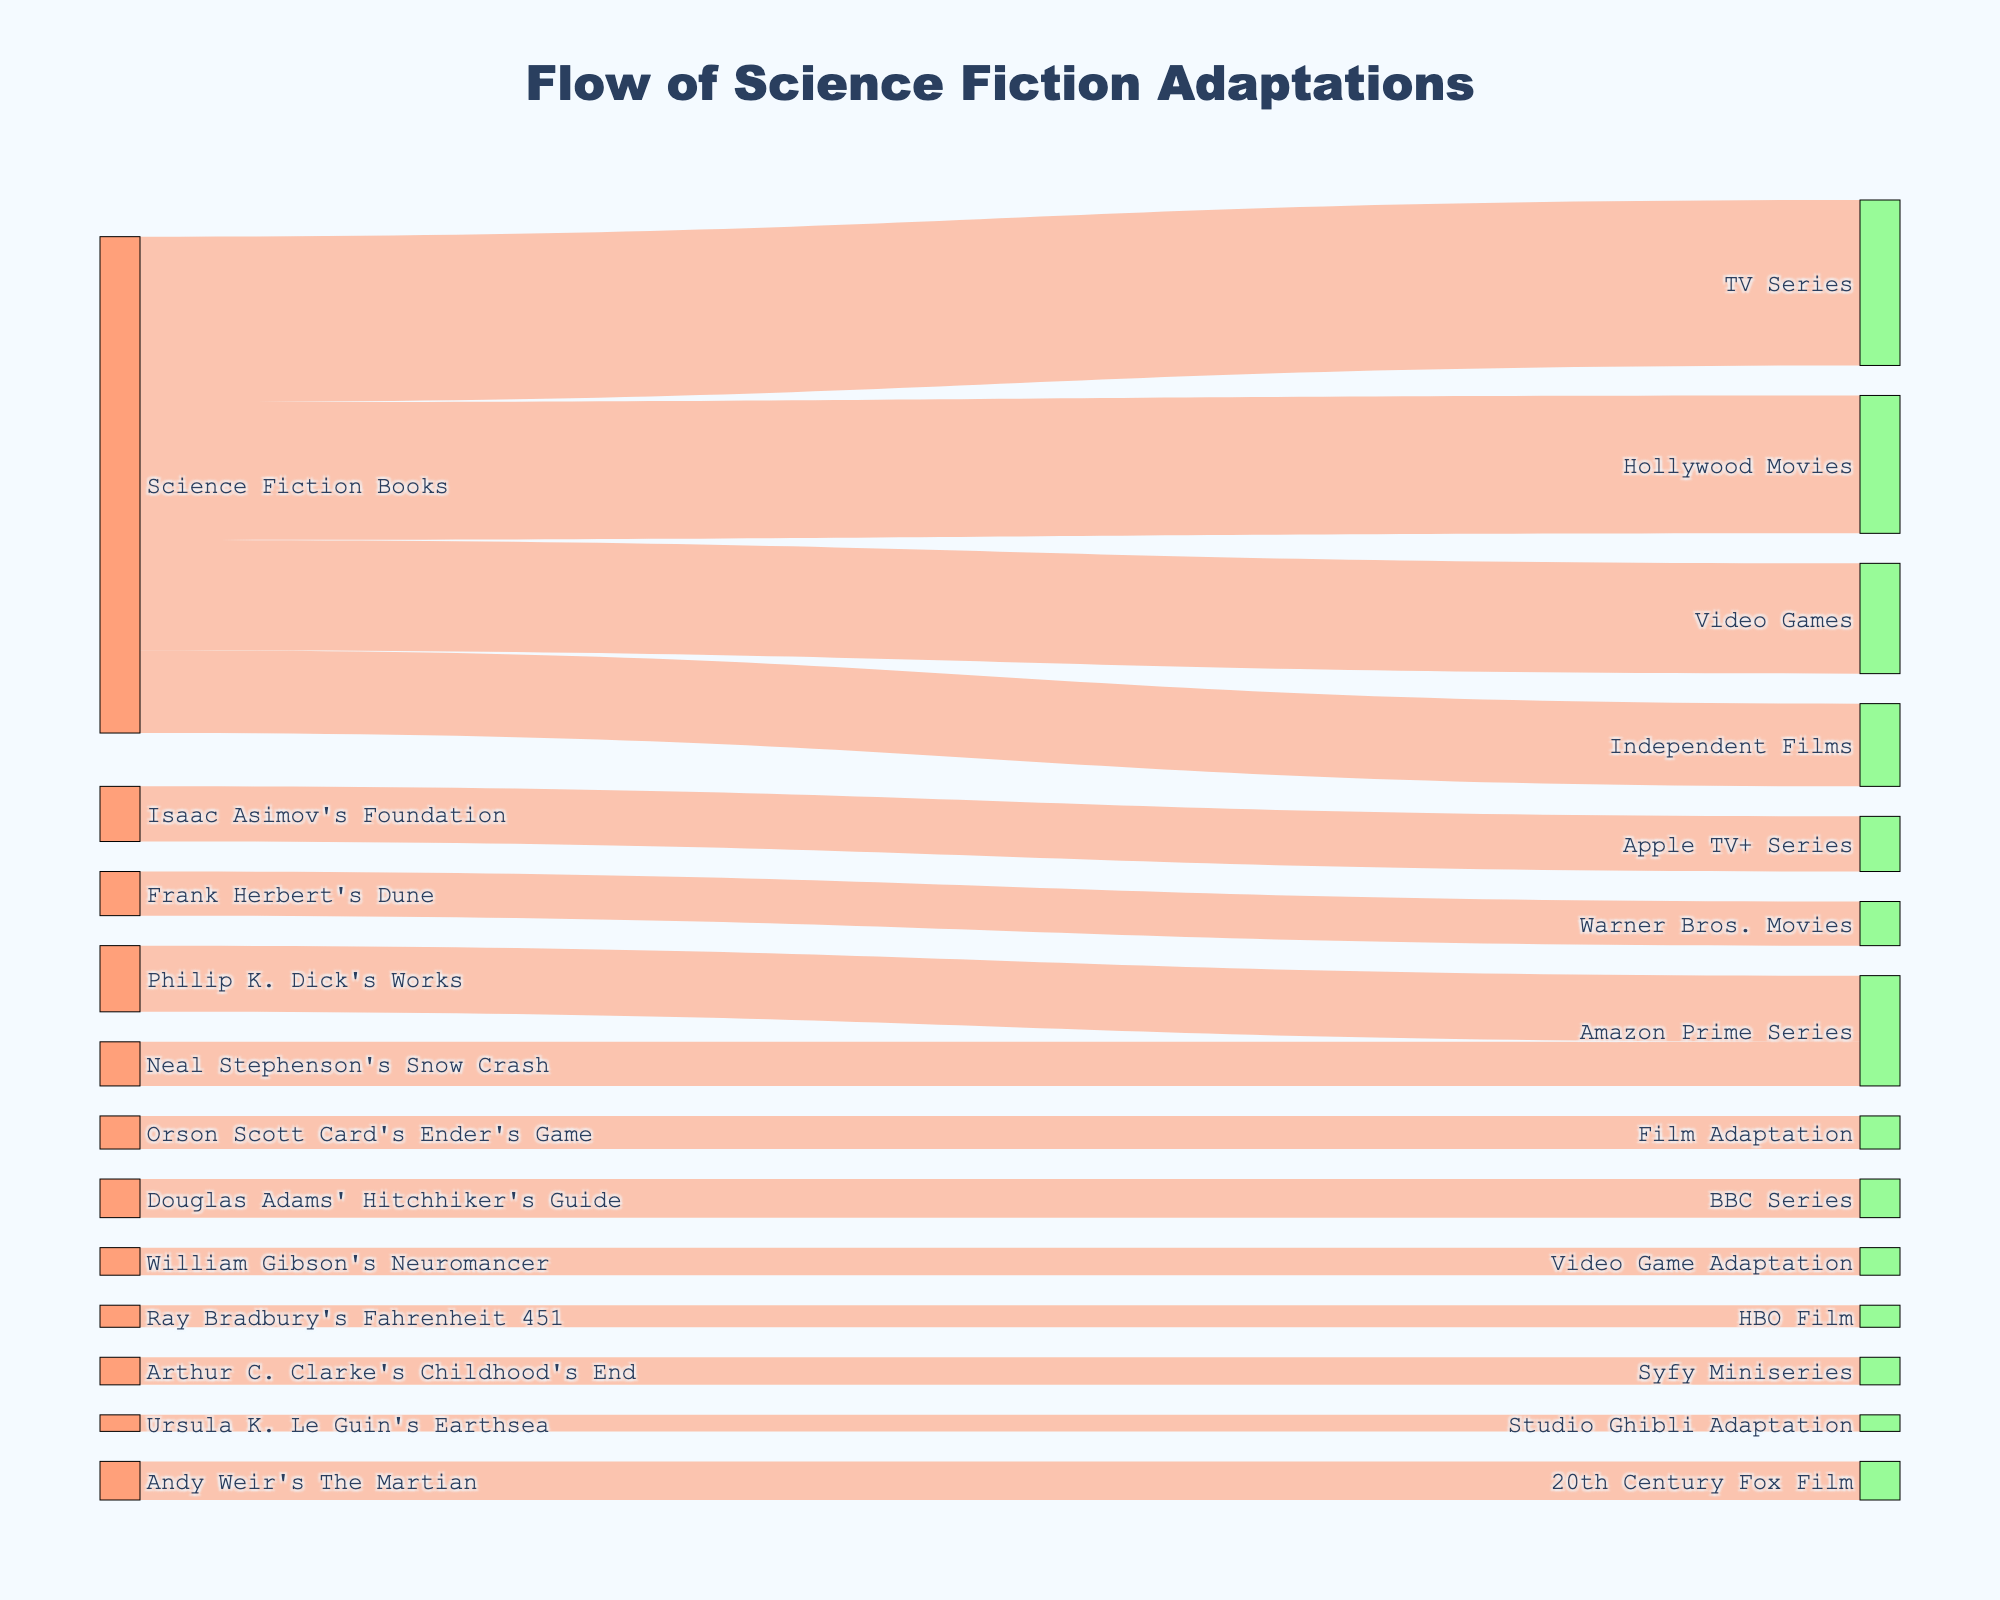What is the title of the figure? The title is shown at the top center of the figure. It reads "Flow of Science Fiction Adaptations".
Answer: Flow of Science Fiction Adaptations What is the total number of adaptations from Science Fiction Books to other media? To find the total number, sum the values of all the links originating from "Science Fiction Books". These values are 25 (Hollywood Movies) + 15 (Independent Films) + 30 (TV Series) + 20 (Video Games) = 90.
Answer: 90 Which adaptation received the most flow from Philip K. Dick's works? Look at the "source" labeled "Philip K. Dick's Works" and find the link with the highest value connecting it to a target. The values are 12 for "Amazon Prime Series".
Answer: Amazon Prime Series What is the difference in the number of adaptations between Hollywood Movies and Independent Films originating from Science Fiction Books? Identify the values for "Hollywood Movies" (25) and "Independent Films" (15) from "Science Fiction Books". Subtract the two values: 25 - 15 = 10.
Answer: 10 How many adaptations did Isaac Asimov's Foundation receive overall? Find all links with the source "Isaac Asimov's Foundation". There is only one link with a value of 10.
Answer: 10 Which author received the least number of adaptations and what is the media type? Identify the link with the smallest value where the source is an author's specific work. The smallest value is 3 for "Ursula K. Le Guin's Earthsea" to "Studio Ghibli Adaptation".
Answer: Ursula K. Le Guin's Earthsea, Studio Ghibli Adaptation How many series adaptations are depicted in the figure? Look for all the targets indicating series. They are "Apple TV+ Series" (10), "Amazon Prime Series" (12 from Philip K. Dick's Works + 8 from Neal Stephenson's Snow Crash = 20), "BBC Series" (7), "Syfy Miniseries" (5). Sum these values: 10 + 20 + 7 + 5 = 42.
Answer: 42 Compare the flow volumes to TV Series and Video Games from Science Fiction Books. Which is greater and by how much? Check the values from "Science Fiction Books" to "TV Series" (30) and "Video Games" (20). The difference is 30 - 20 = 10. TV Series is greater by 10.
Answer: TV Series, 10 Which specific work adapted to a film has the highest flow and what is its value? Among the specific work adaptations to films, check "Frank Herbert's Dune" (Warner Bros. Movies, 8), "Orson Scott Card's Ender's Game" (Film Adaptation, 6), "Ray Bradbury's Fahrenheit 451" (HBO Film, 4), "Andy Weir's The Martian" (20th Century Fox Film, 7). The highest value is 8 for "Frank Herbert's Dune".
Answer: Frank Herbert's Dune, 8 